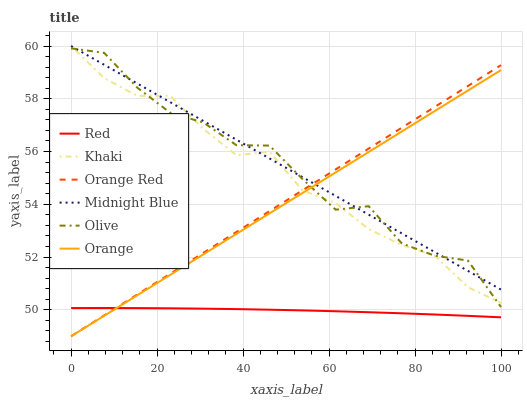Does Red have the minimum area under the curve?
Answer yes or no. Yes. Does Midnight Blue have the maximum area under the curve?
Answer yes or no. Yes. Does Orange have the minimum area under the curve?
Answer yes or no. No. Does Orange have the maximum area under the curve?
Answer yes or no. No. Is Midnight Blue the smoothest?
Answer yes or no. Yes. Is Olive the roughest?
Answer yes or no. Yes. Is Orange the smoothest?
Answer yes or no. No. Is Orange the roughest?
Answer yes or no. No. Does Orange have the lowest value?
Answer yes or no. Yes. Does Midnight Blue have the lowest value?
Answer yes or no. No. Does Midnight Blue have the highest value?
Answer yes or no. Yes. Does Orange have the highest value?
Answer yes or no. No. Is Red less than Khaki?
Answer yes or no. Yes. Is Khaki greater than Red?
Answer yes or no. Yes. Does Khaki intersect Orange Red?
Answer yes or no. Yes. Is Khaki less than Orange Red?
Answer yes or no. No. Is Khaki greater than Orange Red?
Answer yes or no. No. Does Red intersect Khaki?
Answer yes or no. No. 